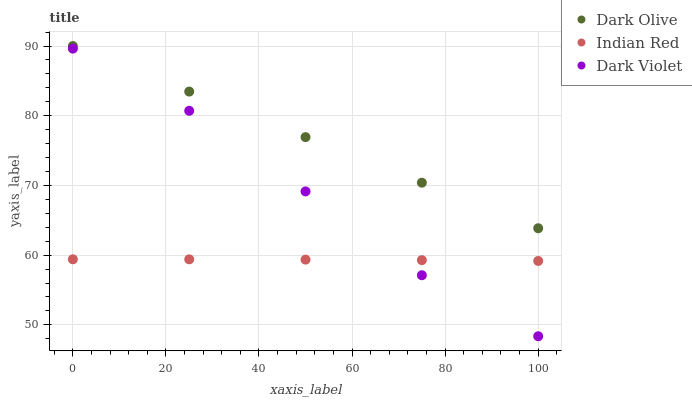Does Indian Red have the minimum area under the curve?
Answer yes or no. Yes. Does Dark Olive have the maximum area under the curve?
Answer yes or no. Yes. Does Dark Violet have the minimum area under the curve?
Answer yes or no. No. Does Dark Violet have the maximum area under the curve?
Answer yes or no. No. Is Dark Olive the smoothest?
Answer yes or no. Yes. Is Dark Violet the roughest?
Answer yes or no. Yes. Is Indian Red the smoothest?
Answer yes or no. No. Is Indian Red the roughest?
Answer yes or no. No. Does Dark Violet have the lowest value?
Answer yes or no. Yes. Does Indian Red have the lowest value?
Answer yes or no. No. Does Dark Olive have the highest value?
Answer yes or no. Yes. Does Dark Violet have the highest value?
Answer yes or no. No. Is Indian Red less than Dark Olive?
Answer yes or no. Yes. Is Dark Olive greater than Indian Red?
Answer yes or no. Yes. Does Dark Violet intersect Indian Red?
Answer yes or no. Yes. Is Dark Violet less than Indian Red?
Answer yes or no. No. Is Dark Violet greater than Indian Red?
Answer yes or no. No. Does Indian Red intersect Dark Olive?
Answer yes or no. No. 